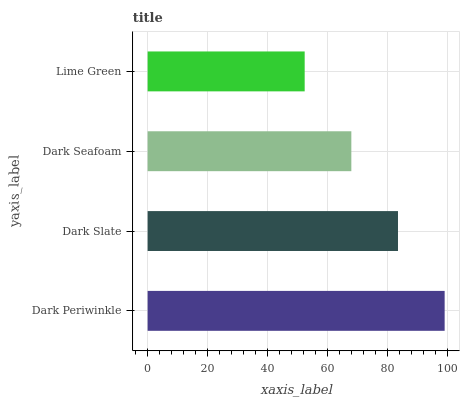Is Lime Green the minimum?
Answer yes or no. Yes. Is Dark Periwinkle the maximum?
Answer yes or no. Yes. Is Dark Slate the minimum?
Answer yes or no. No. Is Dark Slate the maximum?
Answer yes or no. No. Is Dark Periwinkle greater than Dark Slate?
Answer yes or no. Yes. Is Dark Slate less than Dark Periwinkle?
Answer yes or no. Yes. Is Dark Slate greater than Dark Periwinkle?
Answer yes or no. No. Is Dark Periwinkle less than Dark Slate?
Answer yes or no. No. Is Dark Slate the high median?
Answer yes or no. Yes. Is Dark Seafoam the low median?
Answer yes or no. Yes. Is Dark Periwinkle the high median?
Answer yes or no. No. Is Dark Periwinkle the low median?
Answer yes or no. No. 